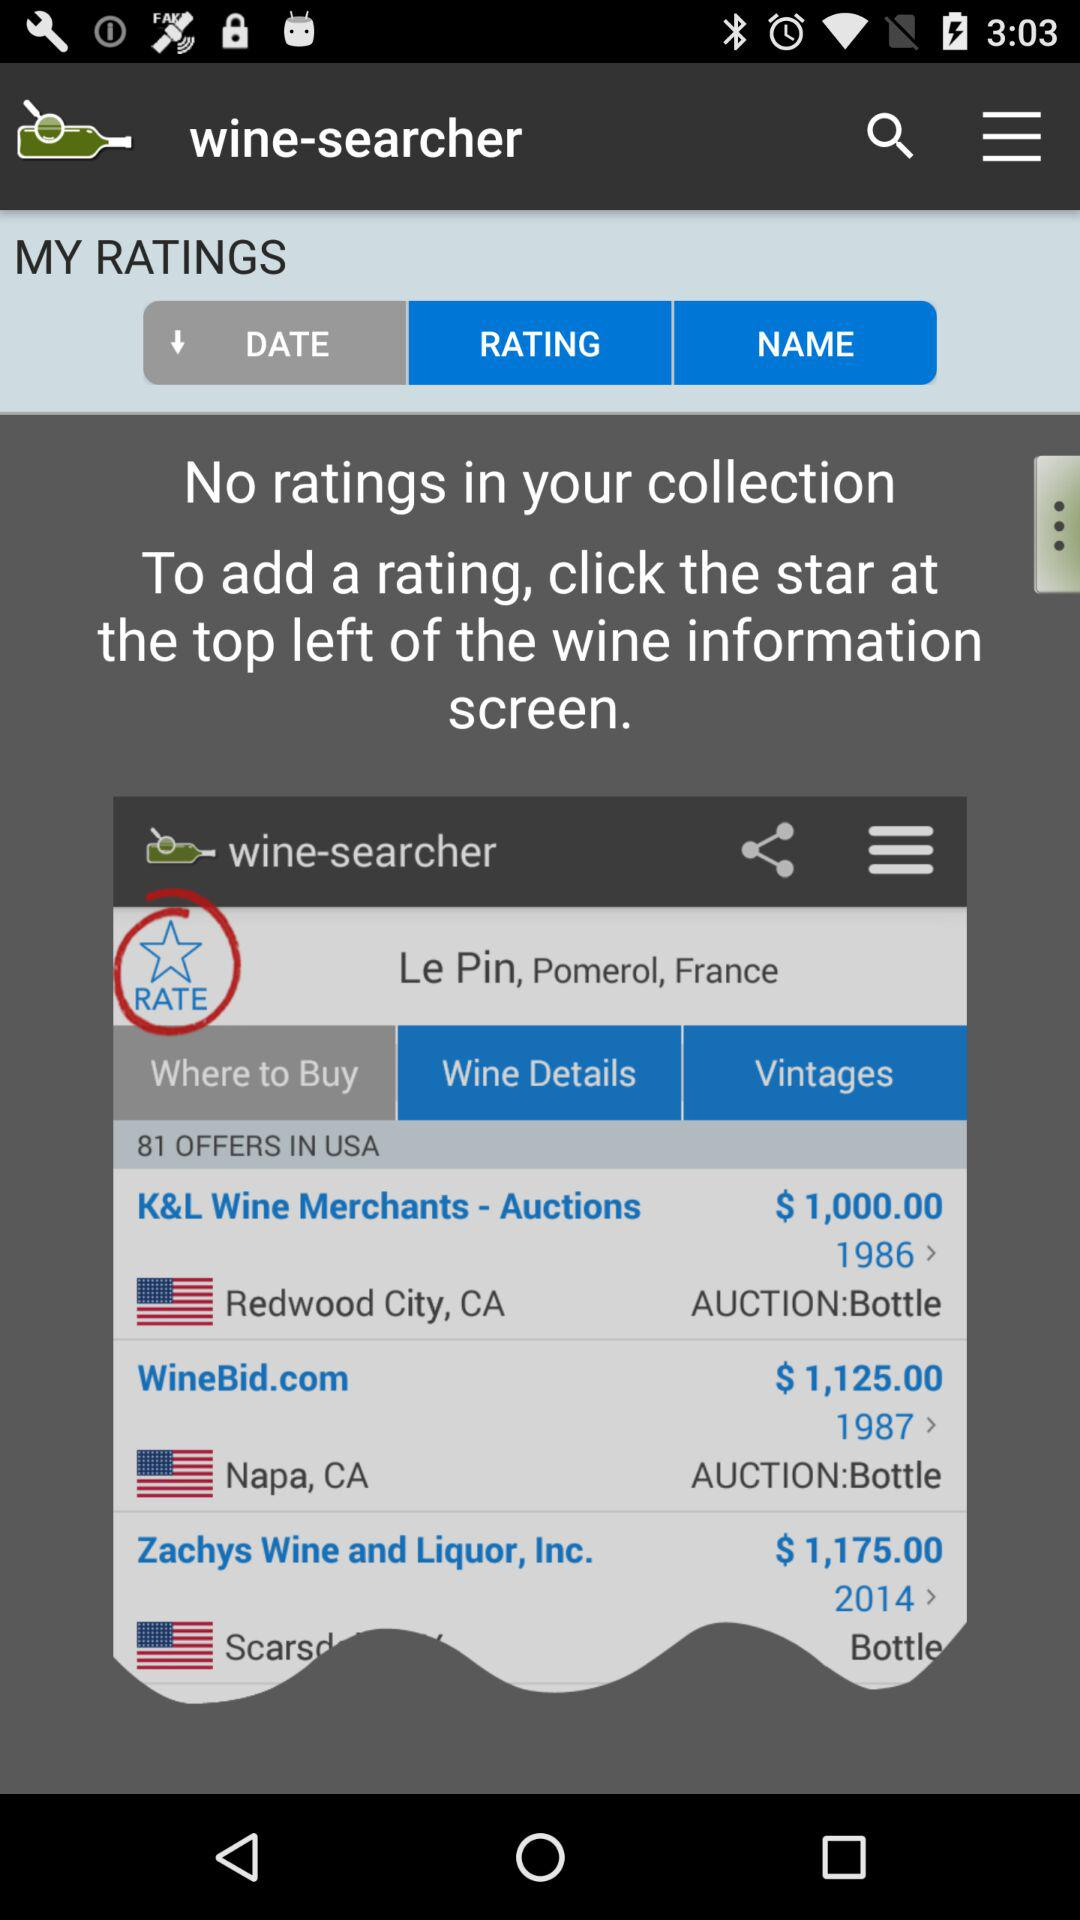How many offers are there for Le Pin, Pomerol, France?
Answer the question using a single word or phrase. 81 